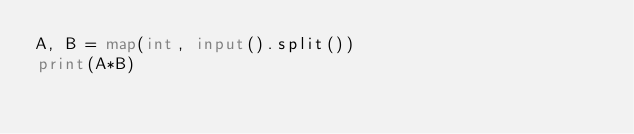Convert code to text. <code><loc_0><loc_0><loc_500><loc_500><_Python_>A, B = map(int, input().split())
print(A*B)
</code> 